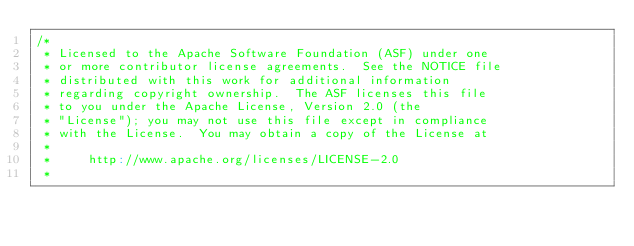<code> <loc_0><loc_0><loc_500><loc_500><_Scala_>/*
 * Licensed to the Apache Software Foundation (ASF) under one
 * or more contributor license agreements.  See the NOTICE file
 * distributed with this work for additional information
 * regarding copyright ownership.  The ASF licenses this file
 * to you under the Apache License, Version 2.0 (the
 * "License"); you may not use this file except in compliance
 * with the License.  You may obtain a copy of the License at
 *
 *     http://www.apache.org/licenses/LICENSE-2.0
 *</code> 